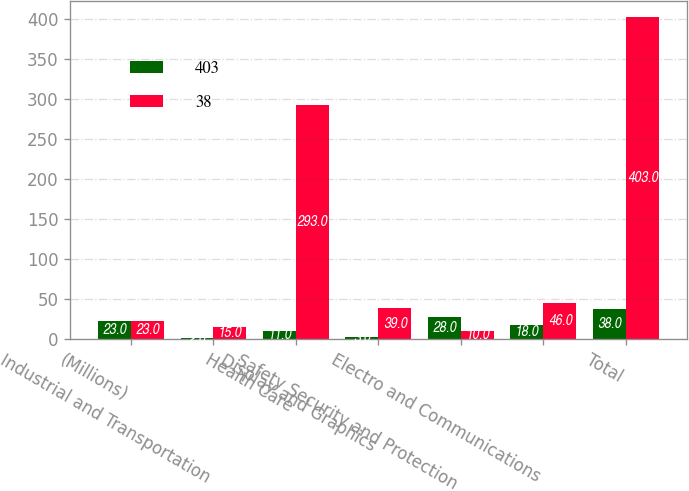<chart> <loc_0><loc_0><loc_500><loc_500><stacked_bar_chart><ecel><fcel>(Millions)<fcel>Industrial and Transportation<fcel>Health Care<fcel>Display and Graphics<fcel>Safety Security and Protection<fcel>Electro and Communications<fcel>Total<nl><fcel>403<fcel>23<fcel>2<fcel>11<fcel>3<fcel>28<fcel>18<fcel>38<nl><fcel>38<fcel>23<fcel>15<fcel>293<fcel>39<fcel>10<fcel>46<fcel>403<nl></chart> 